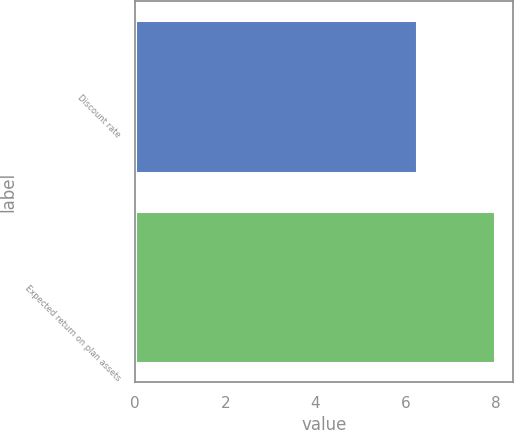Convert chart. <chart><loc_0><loc_0><loc_500><loc_500><bar_chart><fcel>Discount rate<fcel>Expected return on plan assets<nl><fcel>6.25<fcel>8<nl></chart> 